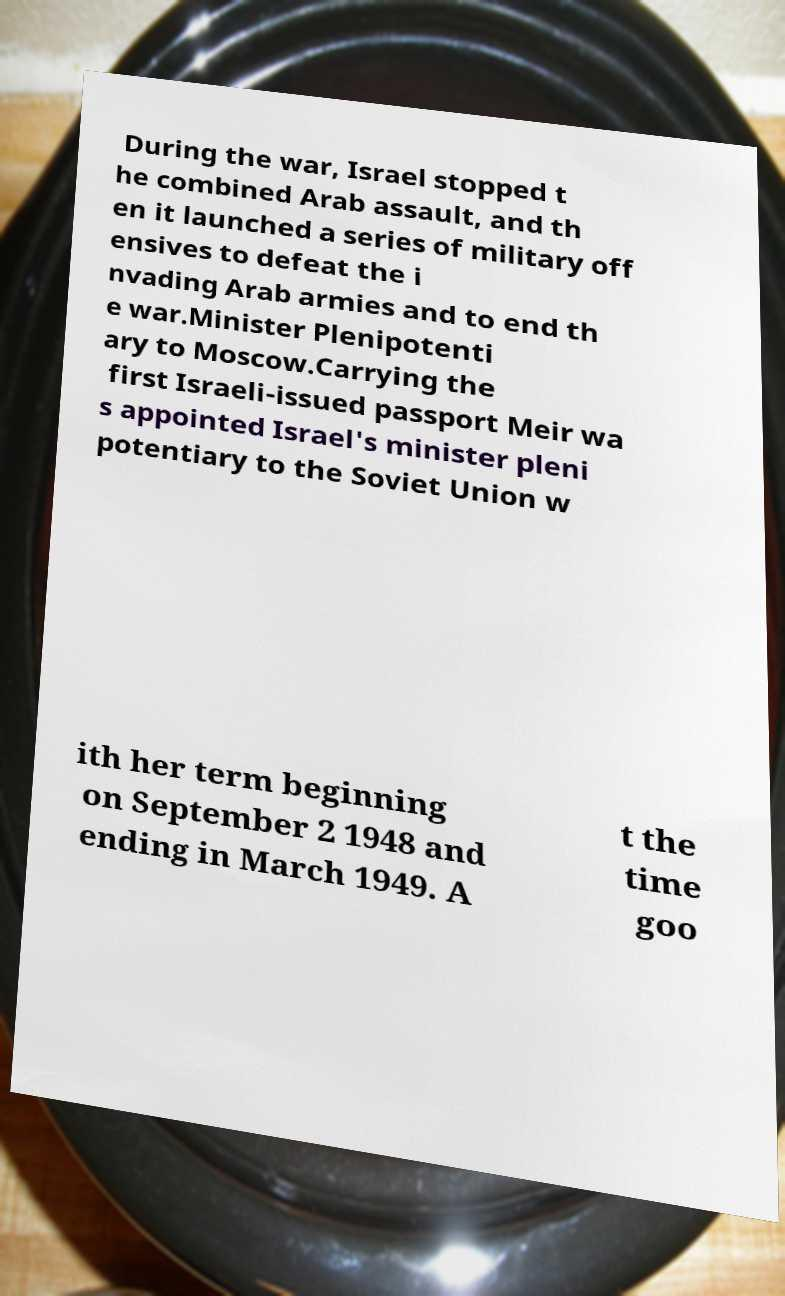Please identify and transcribe the text found in this image. During the war, Israel stopped t he combined Arab assault, and th en it launched a series of military off ensives to defeat the i nvading Arab armies and to end th e war.Minister Plenipotenti ary to Moscow.Carrying the first Israeli-issued passport Meir wa s appointed Israel's minister pleni potentiary to the Soviet Union w ith her term beginning on September 2 1948 and ending in March 1949. A t the time goo 